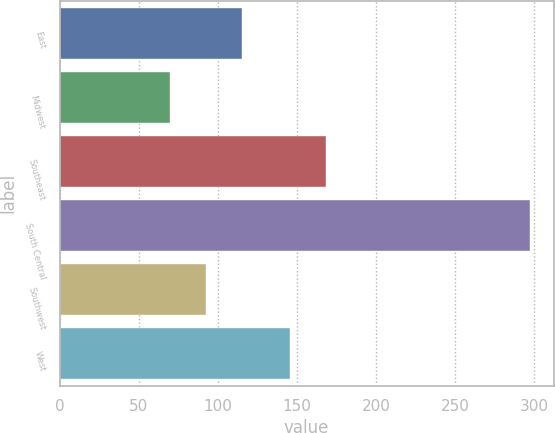<chart> <loc_0><loc_0><loc_500><loc_500><bar_chart><fcel>East<fcel>Midwest<fcel>Southeast<fcel>South Central<fcel>Southwest<fcel>West<nl><fcel>115.54<fcel>70.1<fcel>168.32<fcel>297.3<fcel>92.82<fcel>145.6<nl></chart> 